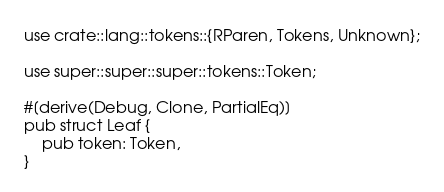<code> <loc_0><loc_0><loc_500><loc_500><_Rust_>use crate::lang::tokens::{RParen, Tokens, Unknown};

use super::super::super::tokens::Token;

#[derive(Debug, Clone, PartialEq)]
pub struct Leaf {
    pub token: Token,
}</code> 